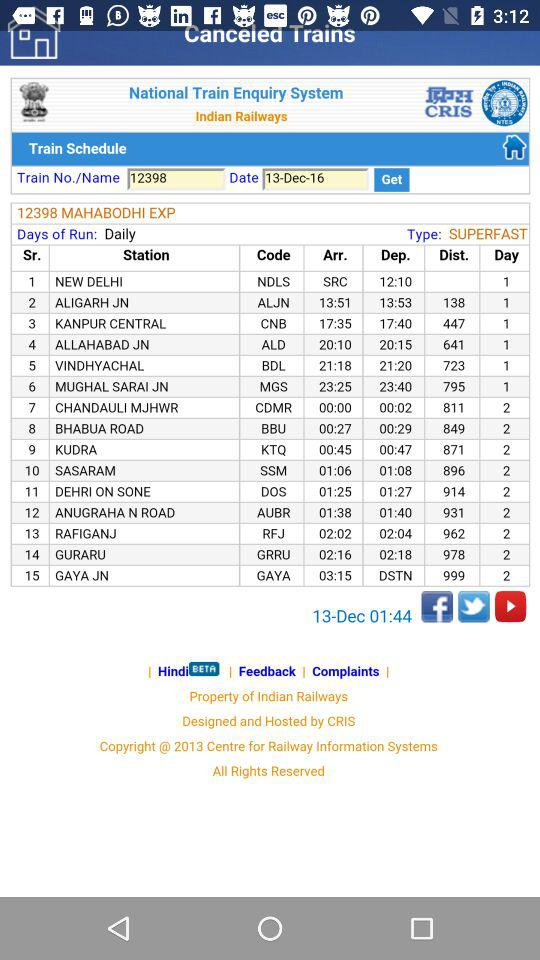What is the departure time from NDLS? The departure time from NDLS is 12:10. 